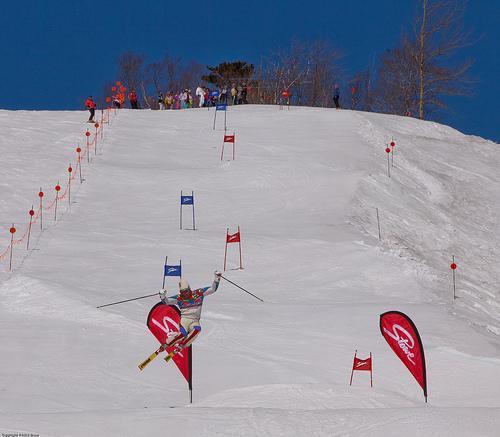How many blue gates are there?
Give a very brief answer. 3. How many people are currently skiing?
Give a very brief answer. 1. 